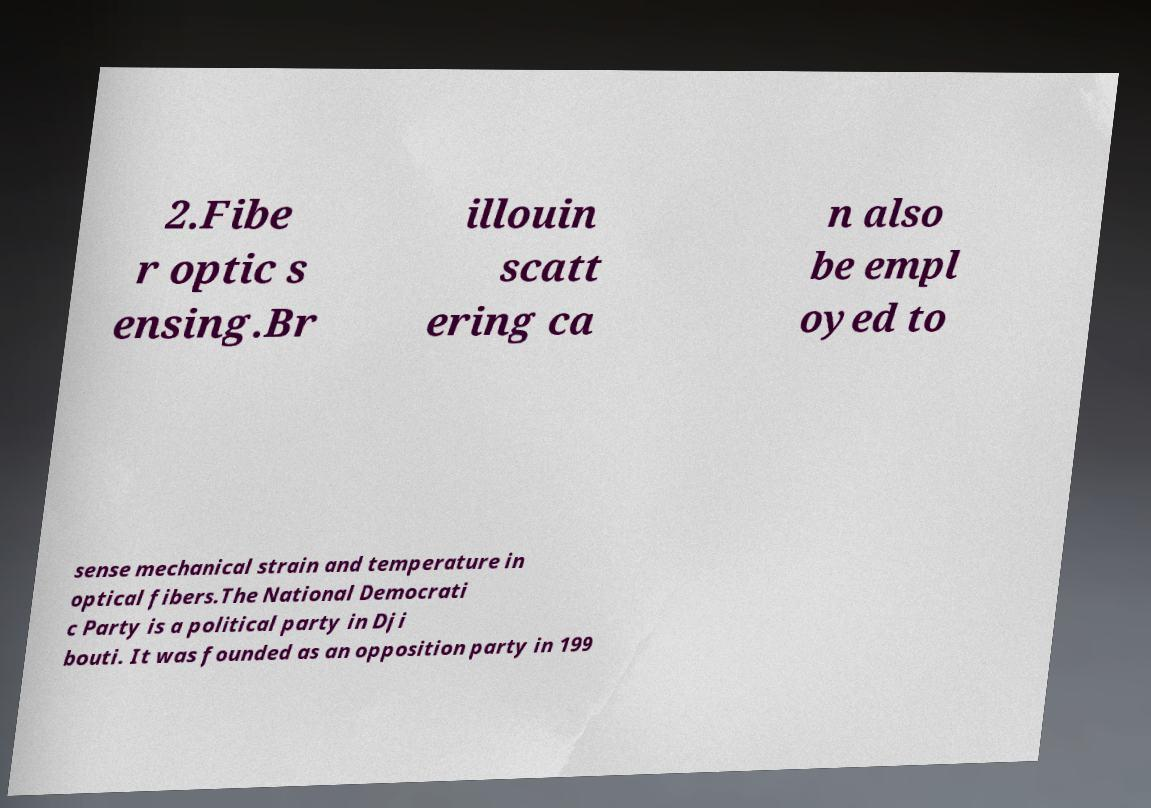Can you read and provide the text displayed in the image?This photo seems to have some interesting text. Can you extract and type it out for me? 2.Fibe r optic s ensing.Br illouin scatt ering ca n also be empl oyed to sense mechanical strain and temperature in optical fibers.The National Democrati c Party is a political party in Dji bouti. It was founded as an opposition party in 199 